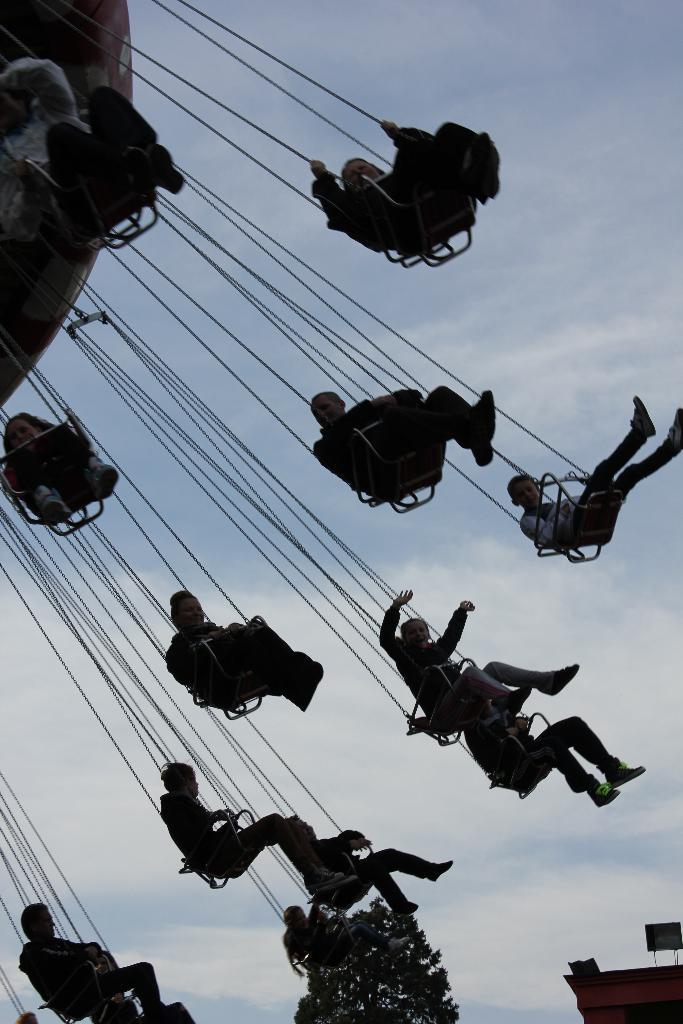What are the persons in the image doing? The persons in the image are enjoying an amusement ride. How do the persons feel while on the ride? The persons have smiles on their faces, indicating that they are happy or enjoying themselves. What can be seen at the bottom of the image? There is a tree at the bottom of the image. What is visible in the sky in the image? There are clouds in the sky. What type of riddle can be solved by the persons on the ride in the image? There is no riddle present in the image, and the persons are not engaged in solving any riddles. How are the persons sorting the items on the ride in the image? There are no items to be sorted on the ride in the image; the persons are simply enjoying the amusement ride. 